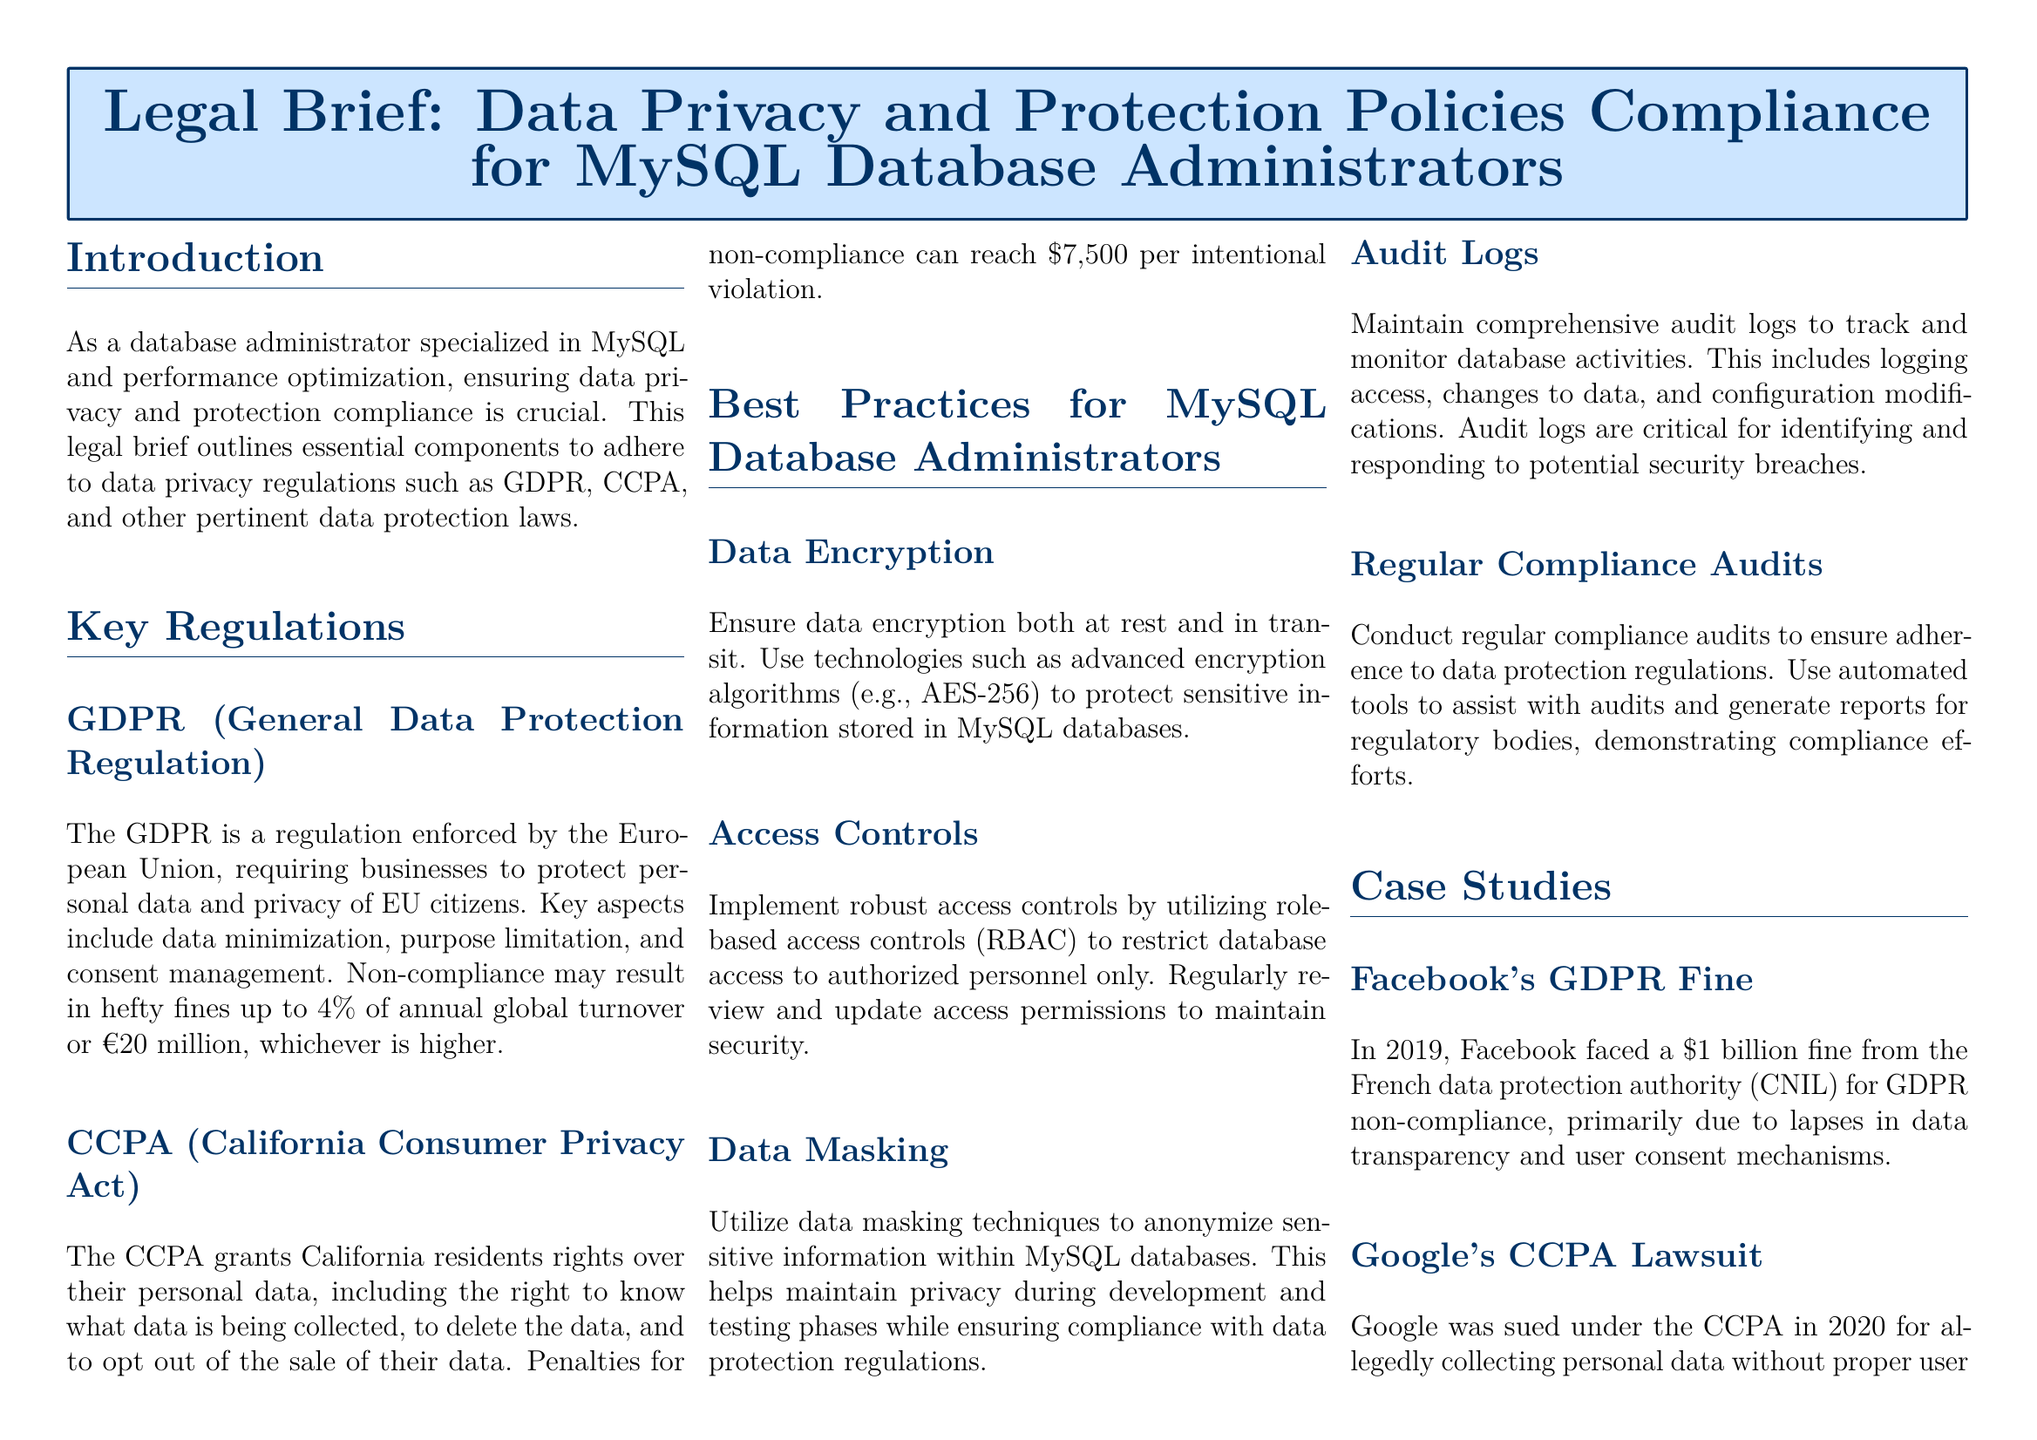What is the primary regulation covered in the document? The primary regulation mentioned in the document is GDPR, which stands for General Data Protection Regulation.
Answer: GDPR What is the penalty for Facebook's GDPR non-compliance? Facebook faced a penalty of 1 billion dollars from CNIL for their GDPR non-compliance.
Answer: 1 billion What encryption standard is recommended for data protection? The document recommends the use of AES-256 as an advanced encryption algorithm for protecting sensitive information.
Answer: AES-256 What is one of the rights granted by the CCPA? One of the rights granted by the CCPA is the right to delete personal data.
Answer: Right to delete What type of access control should be implemented? The document suggests utilizing role-based access controls (RBAC) to restrict database access.
Answer: Role-based access controls What should be maintained to track database activities? Comprehensive audit logs should be maintained to track and monitor database activities as per the document.
Answer: Audit logs How often should compliance audits be conducted? The document recommends conducting regular compliance audits to ensure adherence to data protection regulations.
Answer: Regularly What aspect of data privacy does data masking help with? Data masking helps with anonymizing sensitive information during development and testing phases while ensuring privacy.
Answer: Anonymizing sensitive information What is a key aspect of GDPR? A key aspect of GDPR is data minimization, which emphasizes limiting data collection to necessary information.
Answer: Data minimization 